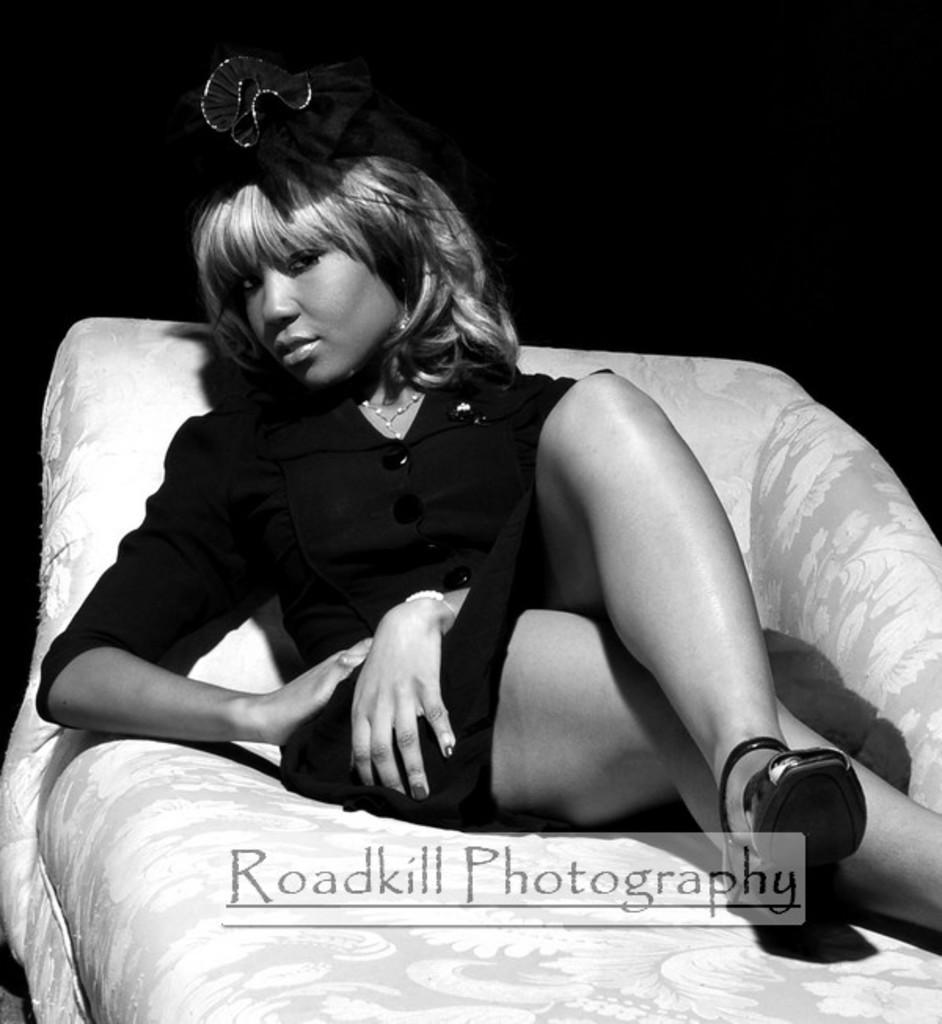How would you summarize this image in a sentence or two? In this image I can see the black and white picture in which I can see the couch which is white and ash in color and a woman wearing black color dress is laying on the couch. I can see the black colored background. 